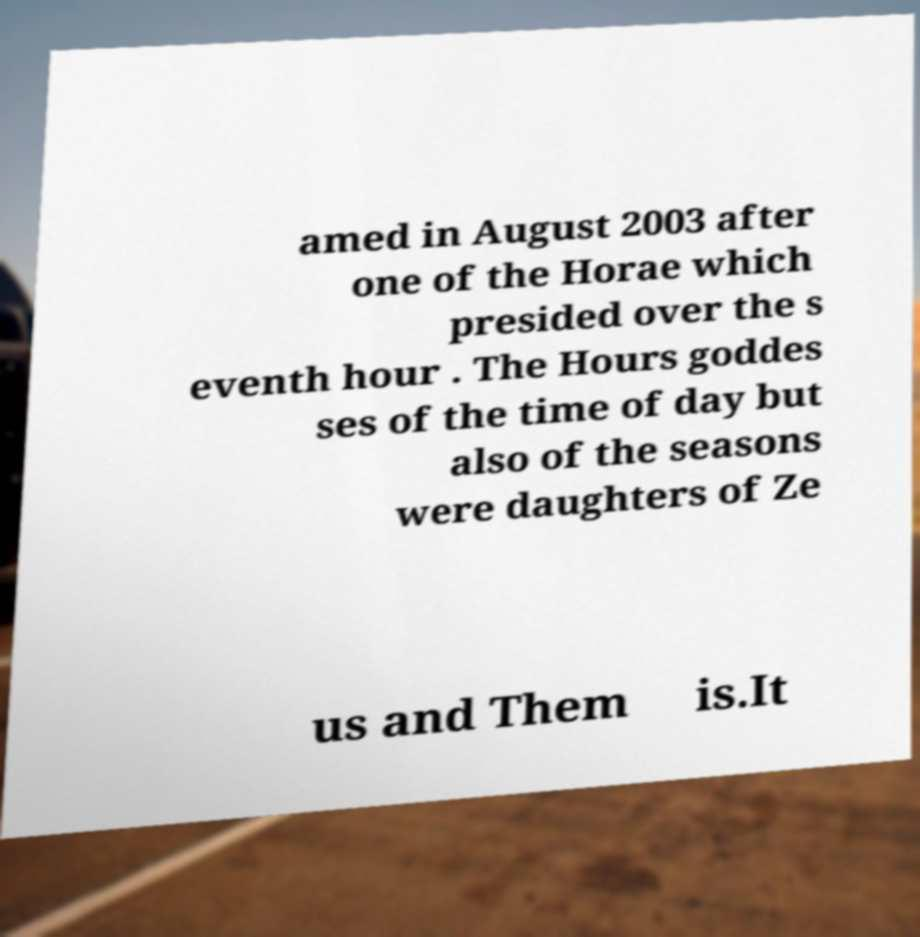There's text embedded in this image that I need extracted. Can you transcribe it verbatim? amed in August 2003 after one of the Horae which presided over the s eventh hour . The Hours goddes ses of the time of day but also of the seasons were daughters of Ze us and Them is.It 